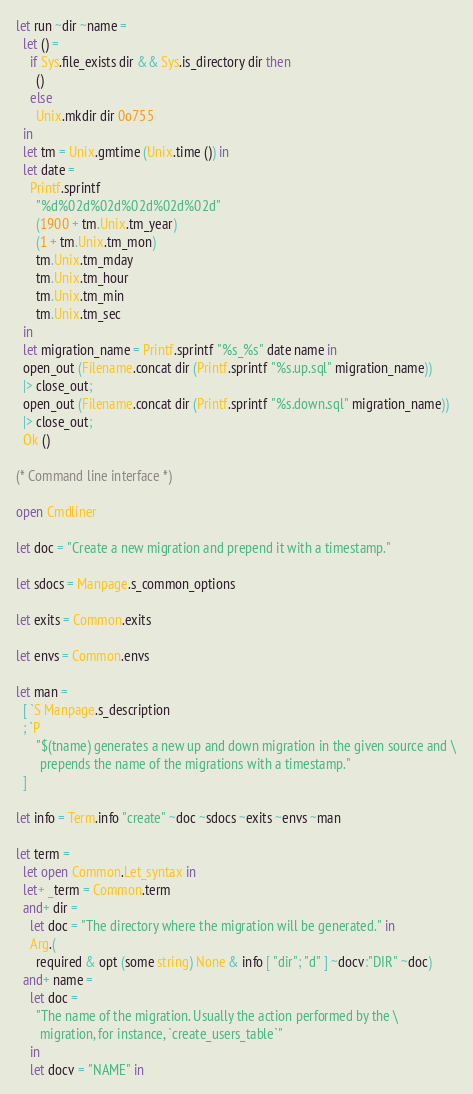<code> <loc_0><loc_0><loc_500><loc_500><_OCaml_>let run ~dir ~name =
  let () =
    if Sys.file_exists dir && Sys.is_directory dir then
      ()
    else
      Unix.mkdir dir 0o755
  in
  let tm = Unix.gmtime (Unix.time ()) in
  let date =
    Printf.sprintf
      "%d%02d%02d%02d%02d%02d"
      (1900 + tm.Unix.tm_year)
      (1 + tm.Unix.tm_mon)
      tm.Unix.tm_mday
      tm.Unix.tm_hour
      tm.Unix.tm_min
      tm.Unix.tm_sec
  in
  let migration_name = Printf.sprintf "%s_%s" date name in
  open_out (Filename.concat dir (Printf.sprintf "%s.up.sql" migration_name))
  |> close_out;
  open_out (Filename.concat dir (Printf.sprintf "%s.down.sql" migration_name))
  |> close_out;
  Ok ()

(* Command line interface *)

open Cmdliner

let doc = "Create a new migration and prepend it with a timestamp."

let sdocs = Manpage.s_common_options

let exits = Common.exits

let envs = Common.envs

let man =
  [ `S Manpage.s_description
  ; `P
      "$(tname) generates a new up and down migration in the given source and \
       prepends the name of the migrations with a timestamp."
  ]

let info = Term.info "create" ~doc ~sdocs ~exits ~envs ~man

let term =
  let open Common.Let_syntax in
  let+ _term = Common.term
  and+ dir =
    let doc = "The directory where the migration will be generated." in
    Arg.(
      required & opt (some string) None & info [ "dir"; "d" ] ~docv:"DIR" ~doc)
  and+ name =
    let doc =
      "The name of the migration. Usually the action performed by the \
       migration, for instance, `create_users_table`"
    in
    let docv = "NAME" in</code> 